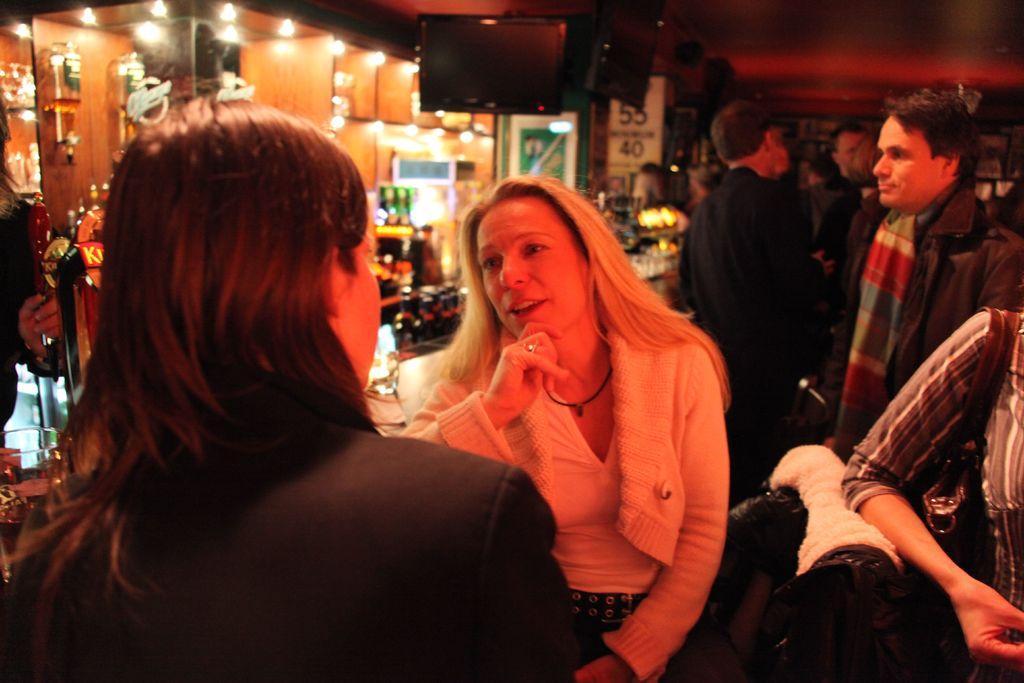How would you summarize this image in a sentence or two? The woman in the middle of the picture wearing white jacket is talking to the woman who is wearing black blazer in the opposite side. Behind her, we see many people standing. Beside them, we see a table on which many alcohol bottles are placed. In the background, we see cupboards and we even see the lights. There is a table on which many alcohol bottles are placed. This picture might be clicked in the bar. 